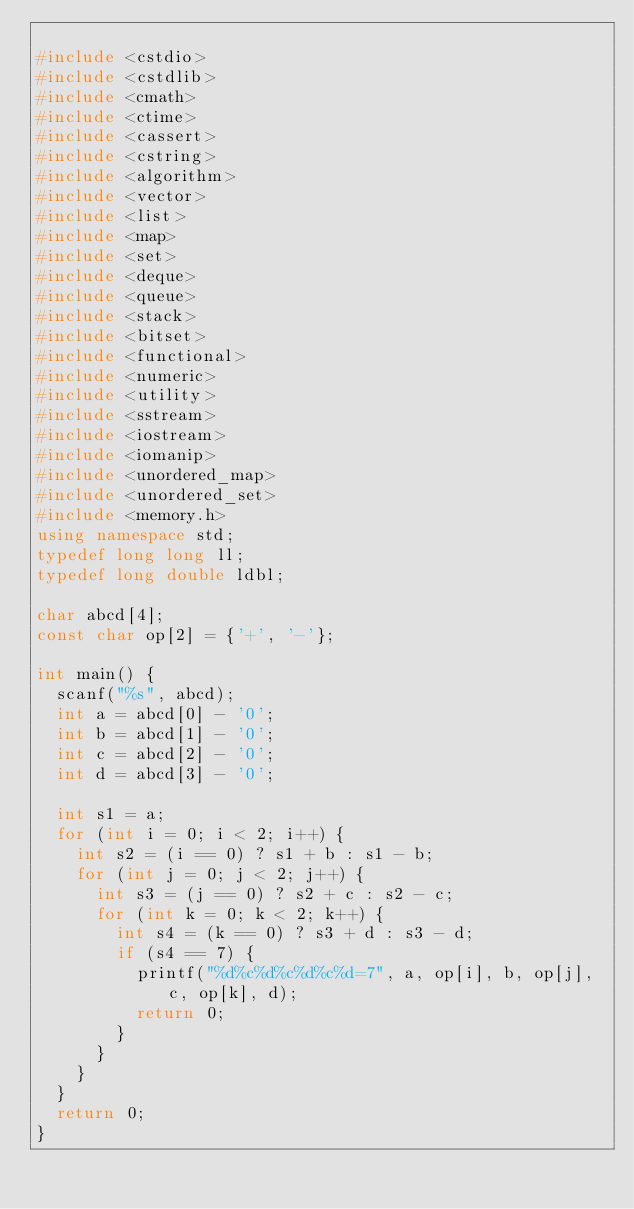<code> <loc_0><loc_0><loc_500><loc_500><_C++_>
#include <cstdio>
#include <cstdlib>
#include <cmath>
#include <ctime>
#include <cassert>
#include <cstring>
#include <algorithm>
#include <vector>
#include <list>
#include <map>
#include <set>
#include <deque>
#include <queue>
#include <stack>
#include <bitset>
#include <functional>
#include <numeric>
#include <utility>
#include <sstream>
#include <iostream>
#include <iomanip>
#include <unordered_map>
#include <unordered_set>
#include <memory.h>
using namespace std;
typedef long long ll;
typedef long double ldbl;

char abcd[4];
const char op[2] = {'+', '-'};

int main() {
  scanf("%s", abcd);
  int a = abcd[0] - '0';
  int b = abcd[1] - '0';
  int c = abcd[2] - '0';
  int d = abcd[3] - '0';

  int s1 = a;
  for (int i = 0; i < 2; i++) {
    int s2 = (i == 0) ? s1 + b : s1 - b;
    for (int j = 0; j < 2; j++) {
      int s3 = (j == 0) ? s2 + c : s2 - c;
      for (int k = 0; k < 2; k++) {
        int s4 = (k == 0) ? s3 + d : s3 - d;
        if (s4 == 7) {
          printf("%d%c%d%c%d%c%d=7", a, op[i], b, op[j], c, op[k], d);
          return 0;
        }
      }
    }
  }
  return 0;
}</code> 